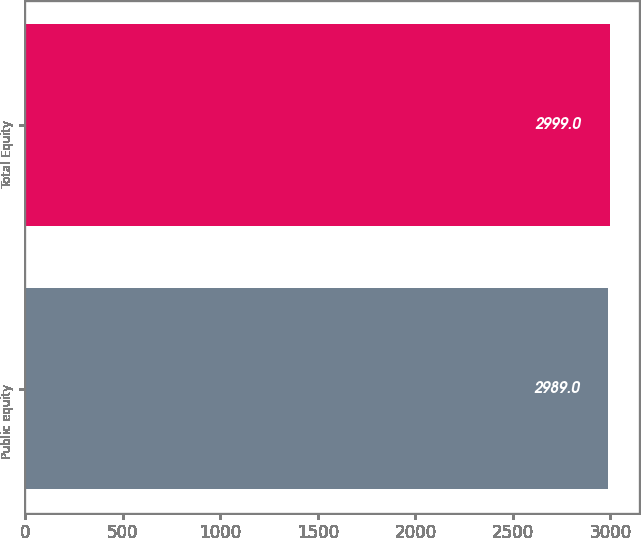Convert chart. <chart><loc_0><loc_0><loc_500><loc_500><bar_chart><fcel>Public equity<fcel>Total Equity<nl><fcel>2989<fcel>2999<nl></chart> 